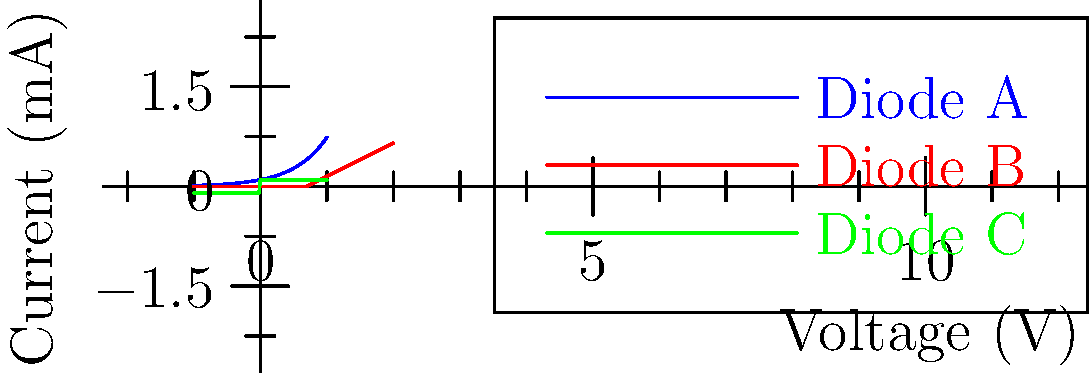As a coffee bean farmer, you understand how different growing conditions impact the flavor profile of coffee. Similarly, in electronics, different types of diodes have unique voltage-current characteristics. Based on the I-V curves shown for three diodes (A, B, and C), which diode exhibits the behavior most similar to an ideal diode, and why might this characteristic be important in circuit design? To answer this question, let's analyze the characteristics of an ideal diode and compare them to the given I-V curves:

1. Ideal diode characteristics:
   - Conducts current only in forward bias (positive voltage)
   - Has a sharp turn-on voltage (usually around 0.7V for silicon diodes)
   - Conducts negligible current in reverse bias

2. Analyzing the given curves:
   - Diode A (blue): Shows exponential current increase with voltage, typical of a standard diode
   - Diode B (red): Exhibits a sharp turn-on voltage and linear current increase afterwards
   - Diode C (green): Shows equal current flow in both directions, unlike a typical diode

3. Comparing to ideal characteristics:
   - Diode B most closely resembles an ideal diode due to its sharp turn-on voltage and linear current increase in forward bias

4. Importance in circuit design:
   - Sharp turn-on voltage allows for precise voltage regulation
   - Linear current increase after turn-on simplifies calculations in circuit analysis
   - Minimal current in reverse bias helps in applications like rectification and signal clipping

Just as selecting the right coffee bean variety for specific growing conditions impacts flavor, choosing the right diode type for a circuit impacts its performance and reliability.
Answer: Diode B; sharp turn-on voltage and linear forward characteristics enable precise voltage regulation and simplified circuit analysis. 